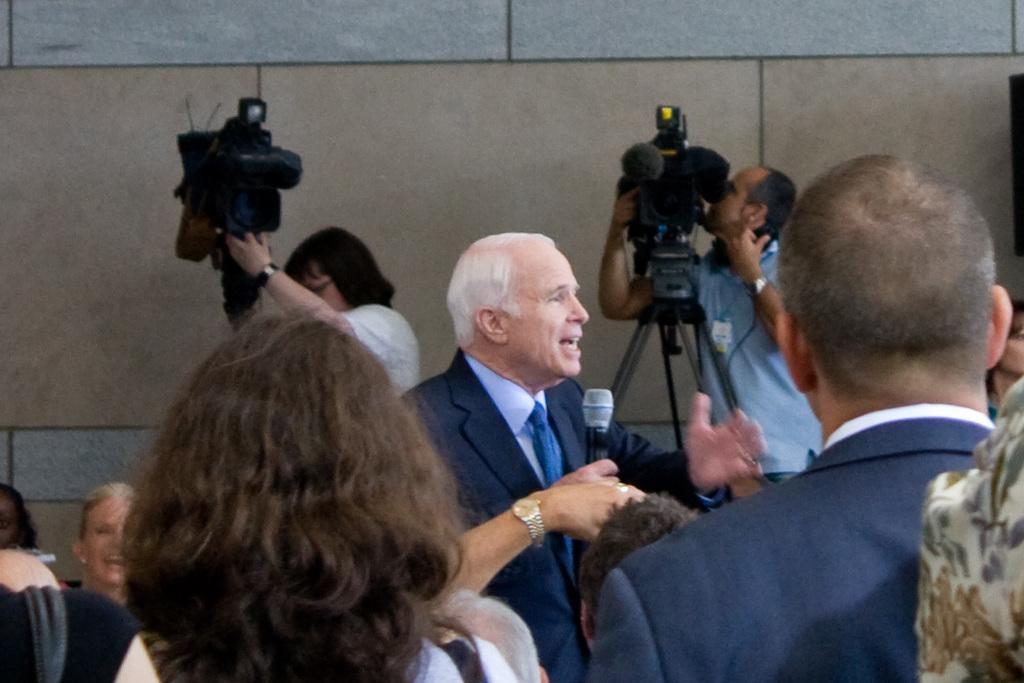In one or two sentences, can you explain what this image depicts? In this image I can see group of people. The person in front wearing black blazer and holding a microphone, background I can see two cameras and wall is in brown and gray color. 